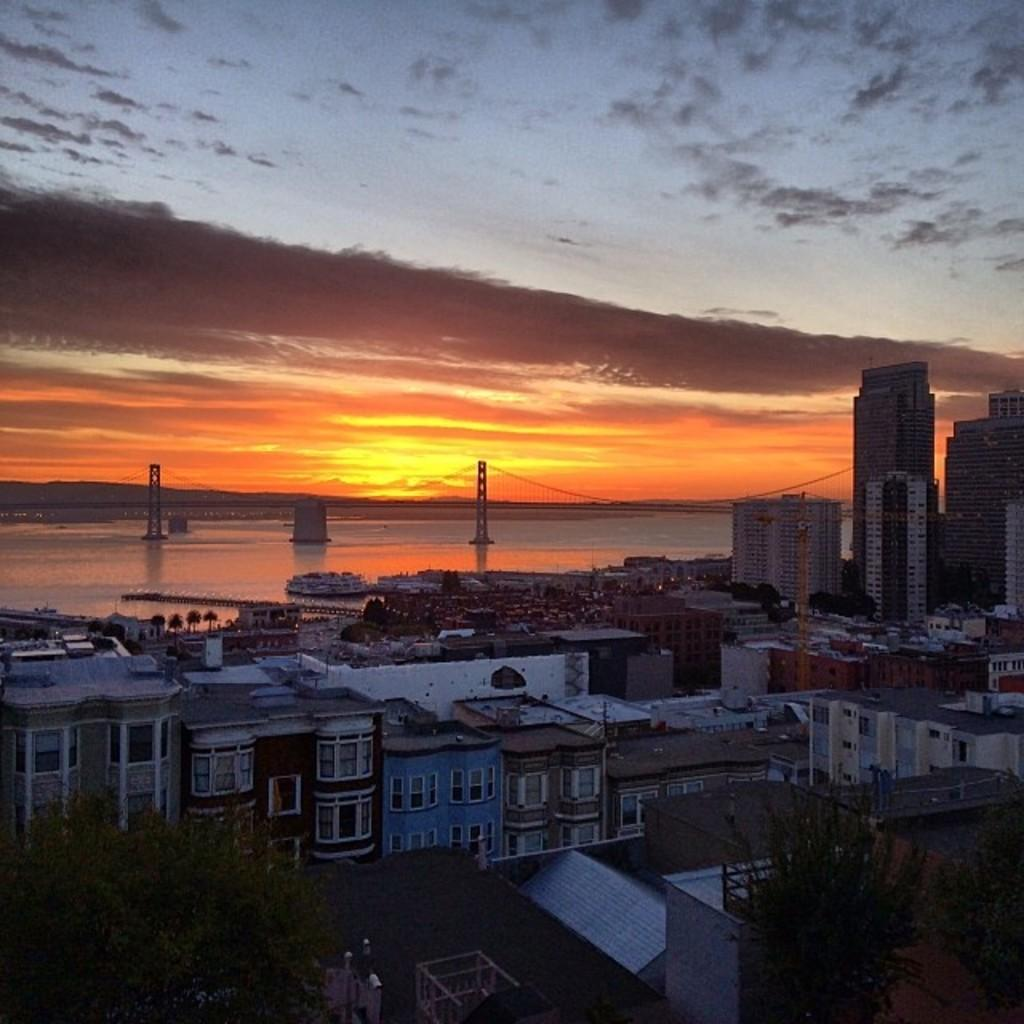What type of structures can be seen in the image? There are many buildings in the image. What other natural elements are present in the image? There are trees in the image. What can be seen in the background of the image? There are boats visible in the background of the image. What architectural feature is present in the image? There is a bridge in the image. What is visible in the sky in the image? There are clouds in the sky, and the sky is visible in the image. Where is the playground located in the image? There is no playground present in the image. What type of thing is hanging from the icicle in the image? There is no icicle present in the image. 